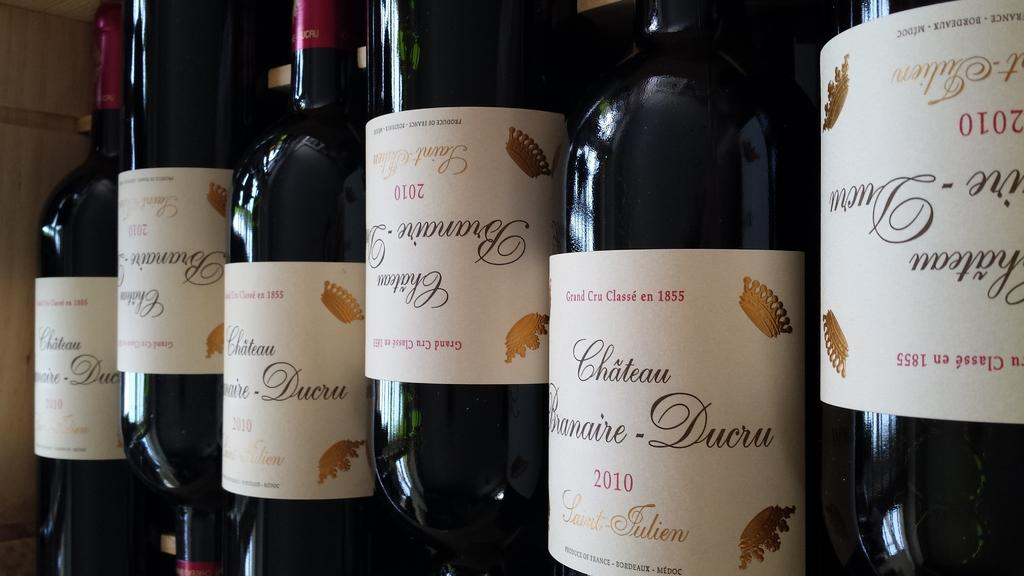<image>
Present a compact description of the photo's key features. Alcohol bottles with a label that says 2010 on it. 